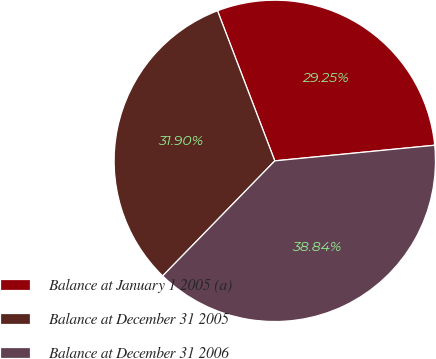<chart> <loc_0><loc_0><loc_500><loc_500><pie_chart><fcel>Balance at January 1 2005 (a)<fcel>Balance at December 31 2005<fcel>Balance at December 31 2006<nl><fcel>29.25%<fcel>31.9%<fcel>38.84%<nl></chart> 